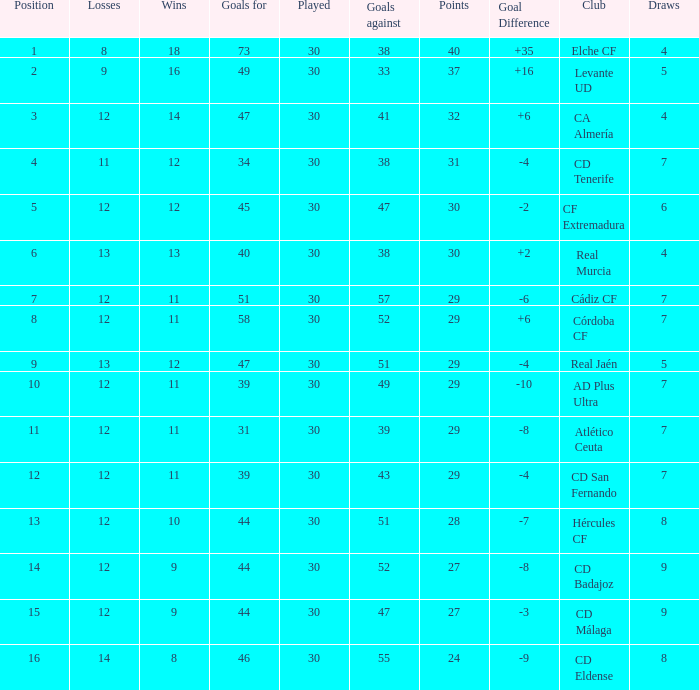What is the sum of the goals with less than 30 points, a position less than 10, and more than 57 goals against? None. 